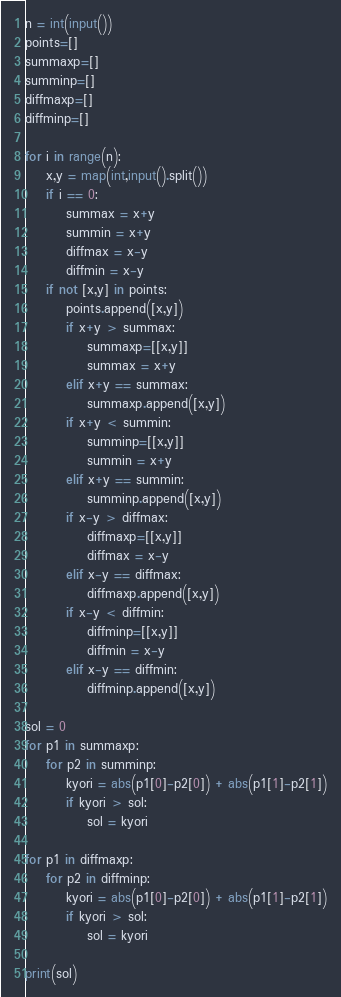<code> <loc_0><loc_0><loc_500><loc_500><_Python_>n = int(input())
points=[]
summaxp=[]
summinp=[]
diffmaxp=[]
diffminp=[]

for i in range(n):
    x,y = map(int,input().split())
    if i == 0:
        summax = x+y
        summin = x+y
        diffmax = x-y
        diffmin = x-y
    if not [x,y] in points:
        points.append([x,y])
        if x+y > summax:
            summaxp=[[x,y]]
            summax = x+y
        elif x+y == summax:
            summaxp.append([x,y])
        if x+y < summin:
            summinp=[[x,y]]
            summin = x+y
        elif x+y == summin:
            summinp.append([x,y])
        if x-y > diffmax:
            diffmaxp=[[x,y]]
            diffmax = x-y
        elif x-y == diffmax:
            diffmaxp.append([x,y])
        if x-y < diffmin:
            diffminp=[[x,y]]
            diffmin = x-y
        elif x-y == diffmin:
            diffminp.append([x,y])

sol = 0
for p1 in summaxp:
    for p2 in summinp:
        kyori = abs(p1[0]-p2[0]) + abs(p1[1]-p2[1])
        if kyori > sol:
            sol = kyori

for p1 in diffmaxp:
    for p2 in diffminp:
        kyori = abs(p1[0]-p2[0]) + abs(p1[1]-p2[1])
        if kyori > sol:
            sol = kyori

print(sol)</code> 